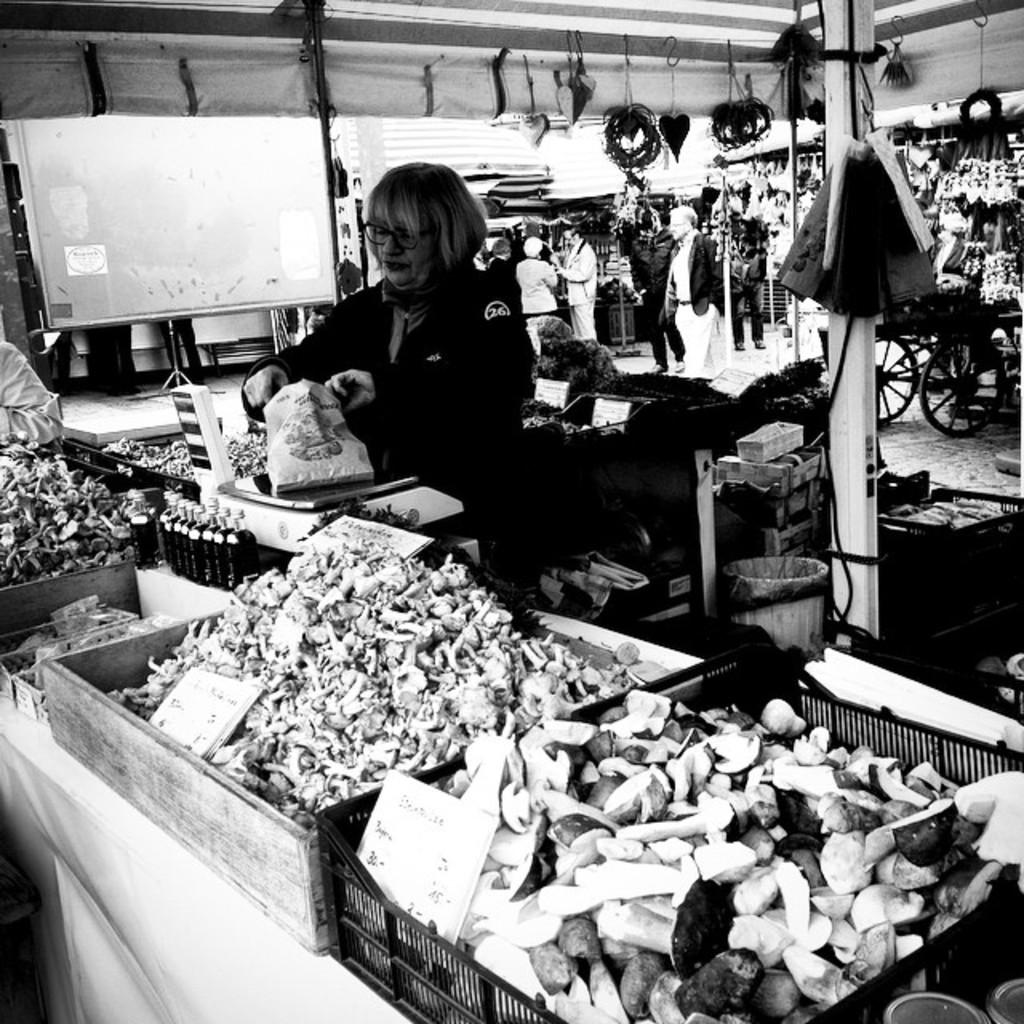What is the color scheme of the image? The image is black and white. What objects can be seen in the image? There are trays in the image. What is on the trays? There are food items on the trays. Where are the people located in the image? There are people under a tent in the image. What time does the clock show in the image? There is no clock present in the image. Can you describe the feather on the passenger's hat in the image? There is no passenger or feather on a hat in the image. 